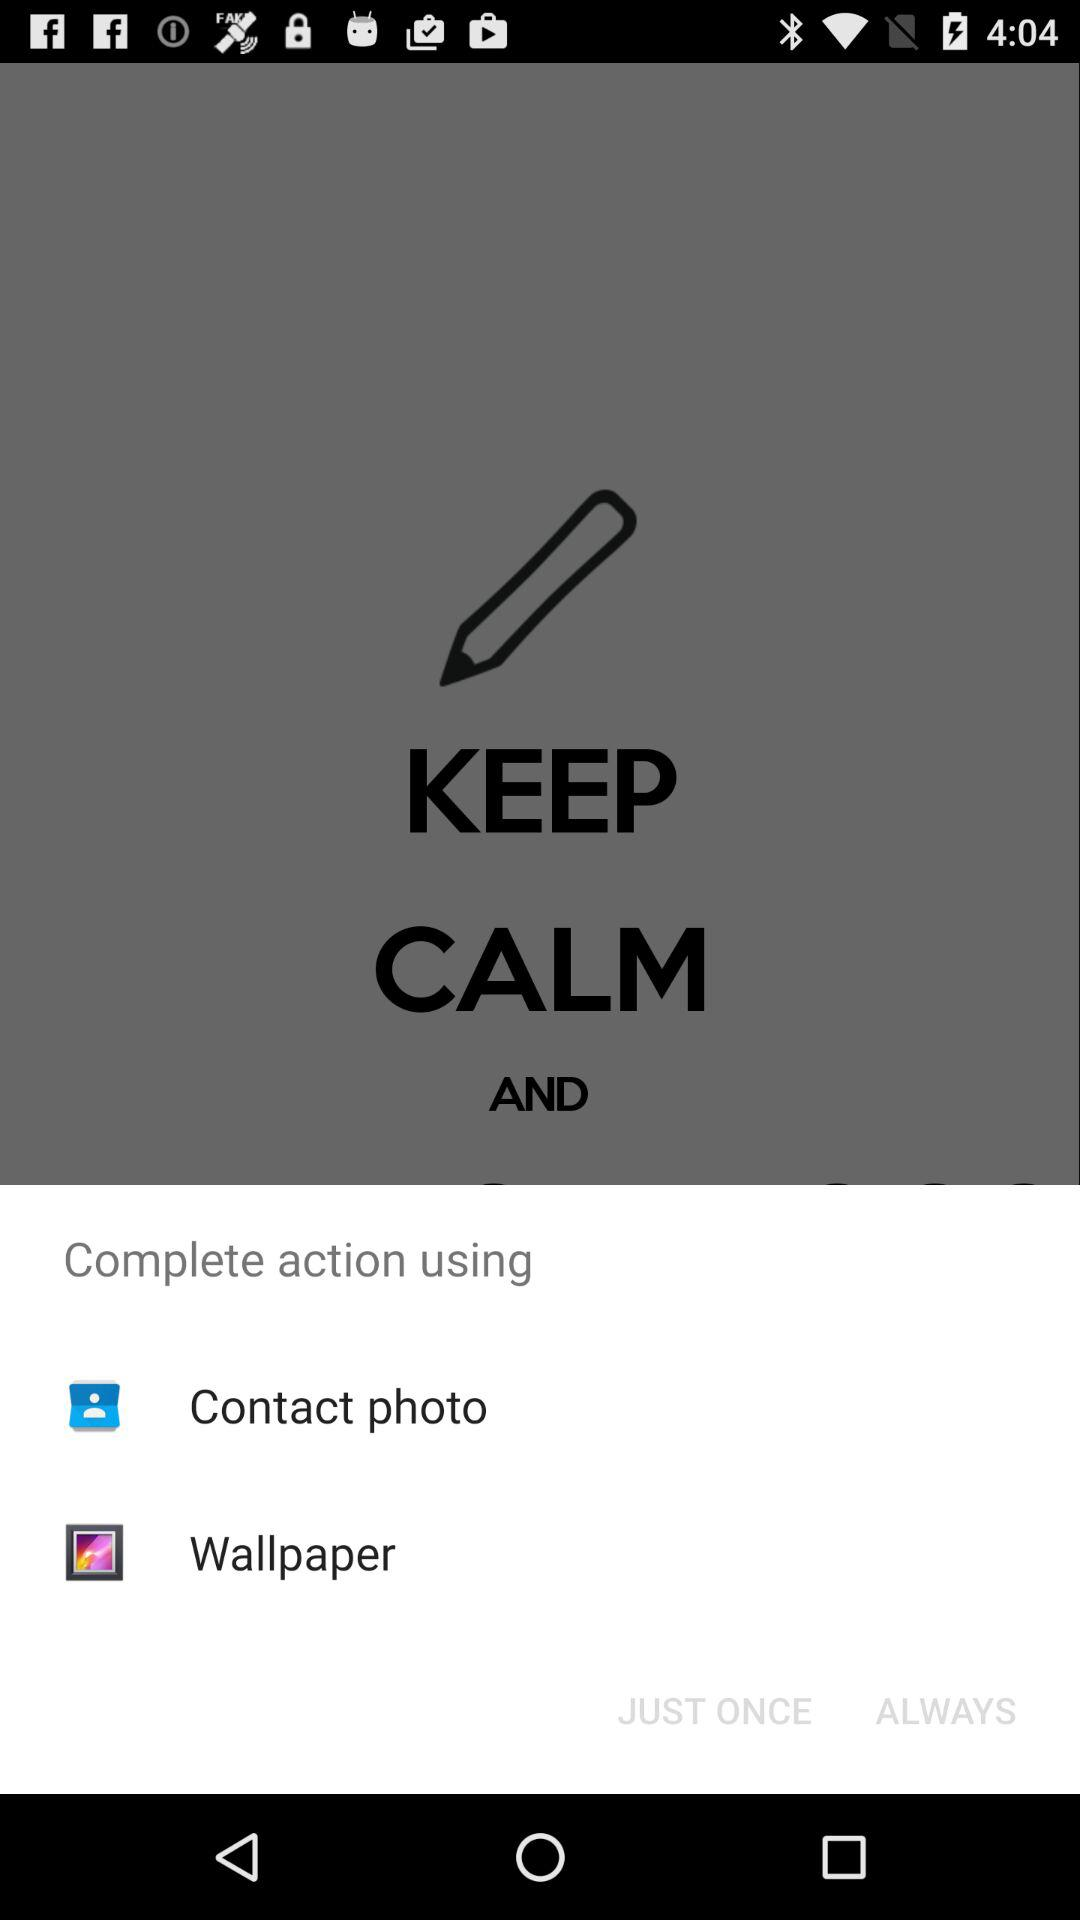What is the version of this application?
When the provided information is insufficient, respond with <no answer>. <no answer> 